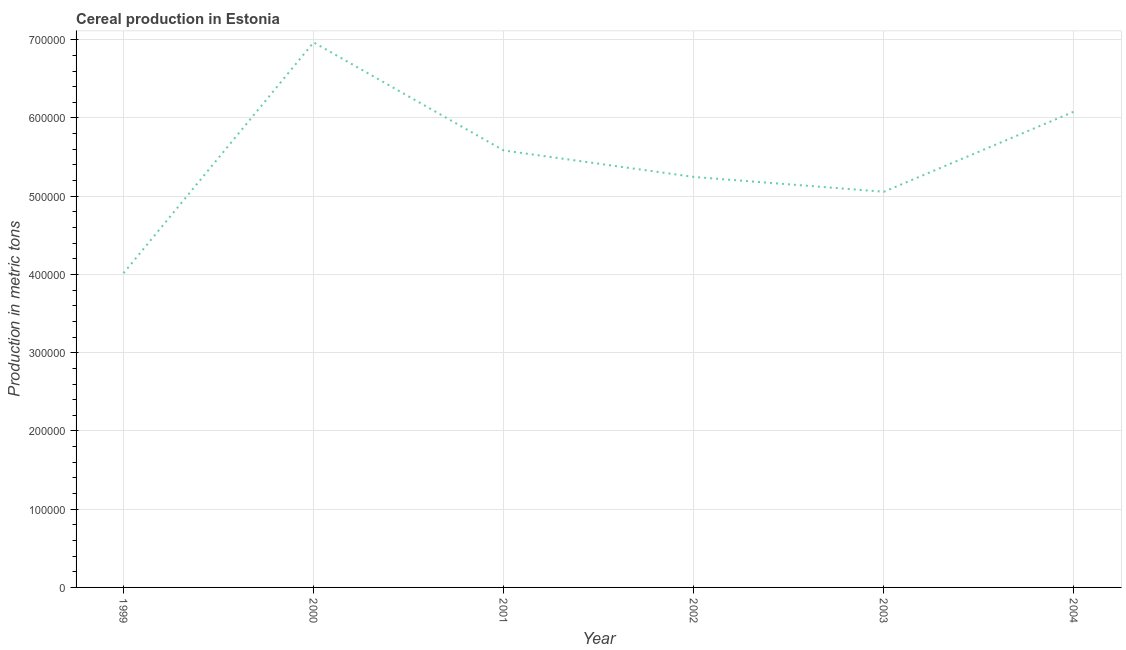What is the cereal production in 2002?
Your answer should be compact. 5.25e+05. Across all years, what is the maximum cereal production?
Offer a very short reply. 6.97e+05. Across all years, what is the minimum cereal production?
Offer a terse response. 4.02e+05. In which year was the cereal production minimum?
Offer a very short reply. 1999. What is the sum of the cereal production?
Your response must be concise. 3.30e+06. What is the difference between the cereal production in 1999 and 2000?
Your answer should be compact. -2.95e+05. What is the average cereal production per year?
Offer a very short reply. 5.49e+05. What is the median cereal production?
Your answer should be compact. 5.42e+05. What is the ratio of the cereal production in 1999 to that in 2002?
Your response must be concise. 0.77. Is the difference between the cereal production in 2003 and 2004 greater than the difference between any two years?
Offer a very short reply. No. What is the difference between the highest and the second highest cereal production?
Make the answer very short. 8.85e+04. What is the difference between the highest and the lowest cereal production?
Provide a succinct answer. 2.95e+05. Does the cereal production monotonically increase over the years?
Keep it short and to the point. No. Are the values on the major ticks of Y-axis written in scientific E-notation?
Your response must be concise. No. Does the graph contain grids?
Ensure brevity in your answer.  Yes. What is the title of the graph?
Keep it short and to the point. Cereal production in Estonia. What is the label or title of the X-axis?
Make the answer very short. Year. What is the label or title of the Y-axis?
Your answer should be compact. Production in metric tons. What is the Production in metric tons in 1999?
Your response must be concise. 4.02e+05. What is the Production in metric tons in 2000?
Your response must be concise. 6.97e+05. What is the Production in metric tons in 2001?
Offer a terse response. 5.58e+05. What is the Production in metric tons of 2002?
Keep it short and to the point. 5.25e+05. What is the Production in metric tons in 2003?
Ensure brevity in your answer.  5.06e+05. What is the Production in metric tons of 2004?
Provide a succinct answer. 6.08e+05. What is the difference between the Production in metric tons in 1999 and 2000?
Your response must be concise. -2.95e+05. What is the difference between the Production in metric tons in 1999 and 2001?
Ensure brevity in your answer.  -1.57e+05. What is the difference between the Production in metric tons in 1999 and 2002?
Offer a terse response. -1.23e+05. What is the difference between the Production in metric tons in 1999 and 2003?
Provide a short and direct response. -1.04e+05. What is the difference between the Production in metric tons in 1999 and 2004?
Make the answer very short. -2.06e+05. What is the difference between the Production in metric tons in 2000 and 2001?
Provide a succinct answer. 1.38e+05. What is the difference between the Production in metric tons in 2000 and 2002?
Your response must be concise. 1.72e+05. What is the difference between the Production in metric tons in 2000 and 2003?
Provide a short and direct response. 1.91e+05. What is the difference between the Production in metric tons in 2000 and 2004?
Give a very brief answer. 8.85e+04. What is the difference between the Production in metric tons in 2001 and 2002?
Keep it short and to the point. 3.38e+04. What is the difference between the Production in metric tons in 2001 and 2003?
Keep it short and to the point. 5.28e+04. What is the difference between the Production in metric tons in 2001 and 2004?
Give a very brief answer. -4.97e+04. What is the difference between the Production in metric tons in 2002 and 2003?
Your response must be concise. 1.89e+04. What is the difference between the Production in metric tons in 2002 and 2004?
Your answer should be very brief. -8.35e+04. What is the difference between the Production in metric tons in 2003 and 2004?
Ensure brevity in your answer.  -1.02e+05. What is the ratio of the Production in metric tons in 1999 to that in 2000?
Make the answer very short. 0.58. What is the ratio of the Production in metric tons in 1999 to that in 2001?
Make the answer very short. 0.72. What is the ratio of the Production in metric tons in 1999 to that in 2002?
Your answer should be compact. 0.77. What is the ratio of the Production in metric tons in 1999 to that in 2003?
Your answer should be compact. 0.79. What is the ratio of the Production in metric tons in 1999 to that in 2004?
Your answer should be compact. 0.66. What is the ratio of the Production in metric tons in 2000 to that in 2001?
Make the answer very short. 1.25. What is the ratio of the Production in metric tons in 2000 to that in 2002?
Ensure brevity in your answer.  1.33. What is the ratio of the Production in metric tons in 2000 to that in 2003?
Give a very brief answer. 1.38. What is the ratio of the Production in metric tons in 2000 to that in 2004?
Offer a terse response. 1.15. What is the ratio of the Production in metric tons in 2001 to that in 2002?
Offer a very short reply. 1.06. What is the ratio of the Production in metric tons in 2001 to that in 2003?
Provide a succinct answer. 1.1. What is the ratio of the Production in metric tons in 2001 to that in 2004?
Your answer should be compact. 0.92. What is the ratio of the Production in metric tons in 2002 to that in 2004?
Ensure brevity in your answer.  0.86. What is the ratio of the Production in metric tons in 2003 to that in 2004?
Provide a succinct answer. 0.83. 